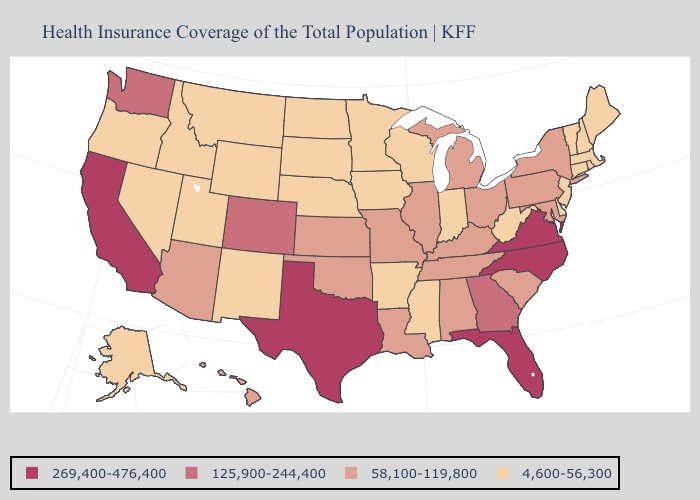Is the legend a continuous bar?
Give a very brief answer. No. Name the states that have a value in the range 125,900-244,400?
Short answer required. Colorado, Georgia, Washington. Does Virginia have the highest value in the USA?
Quick response, please. Yes. Does the first symbol in the legend represent the smallest category?
Concise answer only. No. Name the states that have a value in the range 4,600-56,300?
Quick response, please. Alaska, Arkansas, Connecticut, Delaware, Idaho, Indiana, Iowa, Maine, Massachusetts, Minnesota, Mississippi, Montana, Nebraska, Nevada, New Hampshire, New Jersey, New Mexico, North Dakota, Oregon, Rhode Island, South Dakota, Utah, Vermont, West Virginia, Wisconsin, Wyoming. Among the states that border North Carolina , does Georgia have the lowest value?
Answer briefly. No. Does Wyoming have the same value as North Dakota?
Be succinct. Yes. Name the states that have a value in the range 58,100-119,800?
Keep it brief. Alabama, Arizona, Hawaii, Illinois, Kansas, Kentucky, Louisiana, Maryland, Michigan, Missouri, New York, Ohio, Oklahoma, Pennsylvania, South Carolina, Tennessee. Does Missouri have the highest value in the MidWest?
Be succinct. Yes. Does the first symbol in the legend represent the smallest category?
Be succinct. No. What is the value of New Jersey?
Answer briefly. 4,600-56,300. What is the lowest value in the USA?
Write a very short answer. 4,600-56,300. What is the highest value in the Northeast ?
Keep it brief. 58,100-119,800. Does Ohio have the lowest value in the USA?
Be succinct. No. Among the states that border Alabama , does Florida have the highest value?
Be succinct. Yes. 